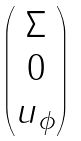<formula> <loc_0><loc_0><loc_500><loc_500>\begin{pmatrix} \begin{matrix} \Sigma \\ 0 \\ u _ { \phi } \end{matrix} \end{pmatrix}</formula> 